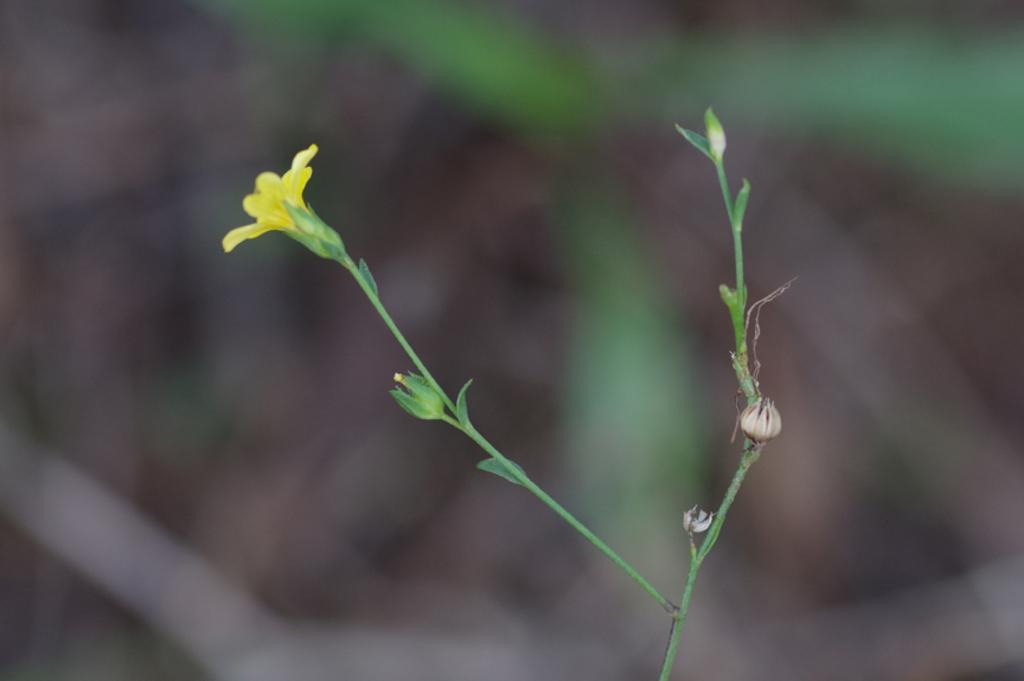What is present in the image? There is a flower in the image. Can you describe the color of the flower? The flower is yellow. How many people are eating lunch in the image? There are no people or lunchroom present in the image; it only features a yellow flower. 